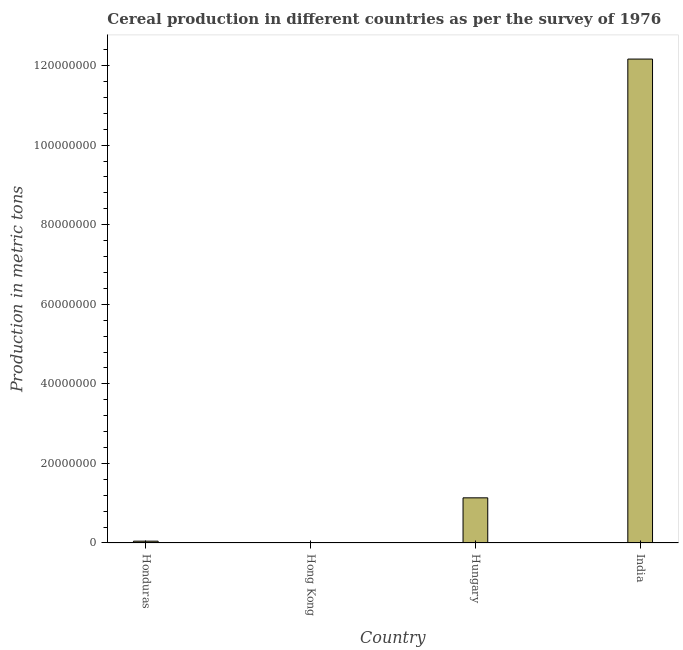What is the title of the graph?
Your response must be concise. Cereal production in different countries as per the survey of 1976. What is the label or title of the X-axis?
Offer a terse response. Country. What is the label or title of the Y-axis?
Your answer should be very brief. Production in metric tons. What is the cereal production in India?
Your answer should be very brief. 1.22e+08. Across all countries, what is the maximum cereal production?
Offer a very short reply. 1.22e+08. Across all countries, what is the minimum cereal production?
Provide a short and direct response. 3450. In which country was the cereal production minimum?
Offer a terse response. Hong Kong. What is the sum of the cereal production?
Provide a short and direct response. 1.33e+08. What is the difference between the cereal production in Honduras and Hungary?
Your answer should be very brief. -1.09e+07. What is the average cereal production per country?
Ensure brevity in your answer.  3.34e+07. What is the median cereal production?
Provide a short and direct response. 5.90e+06. What is the ratio of the cereal production in Hong Kong to that in Hungary?
Your answer should be very brief. 0. What is the difference between the highest and the second highest cereal production?
Give a very brief answer. 1.10e+08. Is the sum of the cereal production in Hong Kong and India greater than the maximum cereal production across all countries?
Offer a terse response. Yes. What is the difference between the highest and the lowest cereal production?
Offer a very short reply. 1.22e+08. How many bars are there?
Provide a succinct answer. 4. What is the difference between two consecutive major ticks on the Y-axis?
Keep it short and to the point. 2.00e+07. What is the Production in metric tons in Honduras?
Offer a very short reply. 4.60e+05. What is the Production in metric tons of Hong Kong?
Keep it short and to the point. 3450. What is the Production in metric tons in Hungary?
Offer a terse response. 1.13e+07. What is the Production in metric tons of India?
Provide a short and direct response. 1.22e+08. What is the difference between the Production in metric tons in Honduras and Hong Kong?
Provide a succinct answer. 4.57e+05. What is the difference between the Production in metric tons in Honduras and Hungary?
Offer a very short reply. -1.09e+07. What is the difference between the Production in metric tons in Honduras and India?
Give a very brief answer. -1.21e+08. What is the difference between the Production in metric tons in Hong Kong and Hungary?
Make the answer very short. -1.13e+07. What is the difference between the Production in metric tons in Hong Kong and India?
Offer a terse response. -1.22e+08. What is the difference between the Production in metric tons in Hungary and India?
Your answer should be compact. -1.10e+08. What is the ratio of the Production in metric tons in Honduras to that in Hong Kong?
Make the answer very short. 133.43. What is the ratio of the Production in metric tons in Honduras to that in Hungary?
Ensure brevity in your answer.  0.04. What is the ratio of the Production in metric tons in Honduras to that in India?
Offer a very short reply. 0. What is the ratio of the Production in metric tons in Hong Kong to that in Hungary?
Your response must be concise. 0. What is the ratio of the Production in metric tons in Hungary to that in India?
Keep it short and to the point. 0.09. 